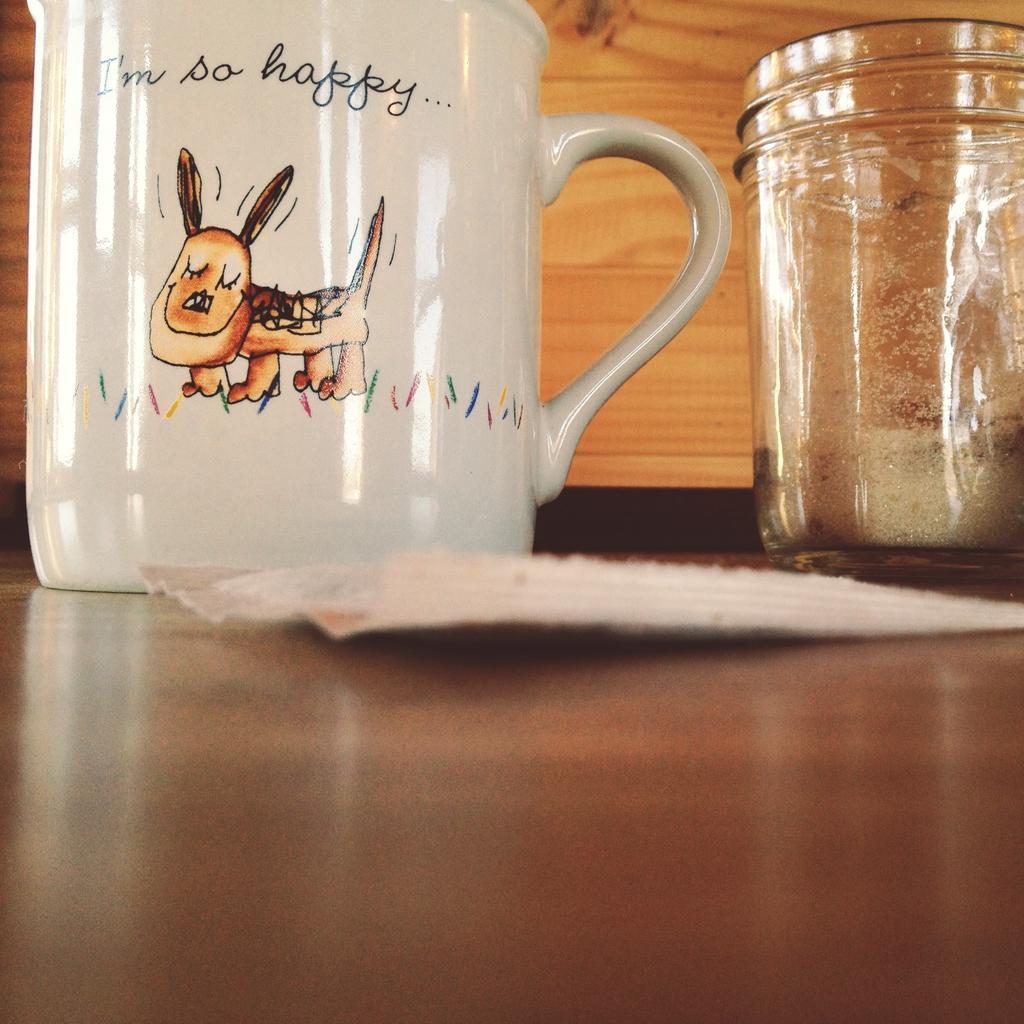Could you give a brief overview of what you see in this image? In the picture there is a jar, a white color mug , a paper on the table there is a dog image on the mug. 